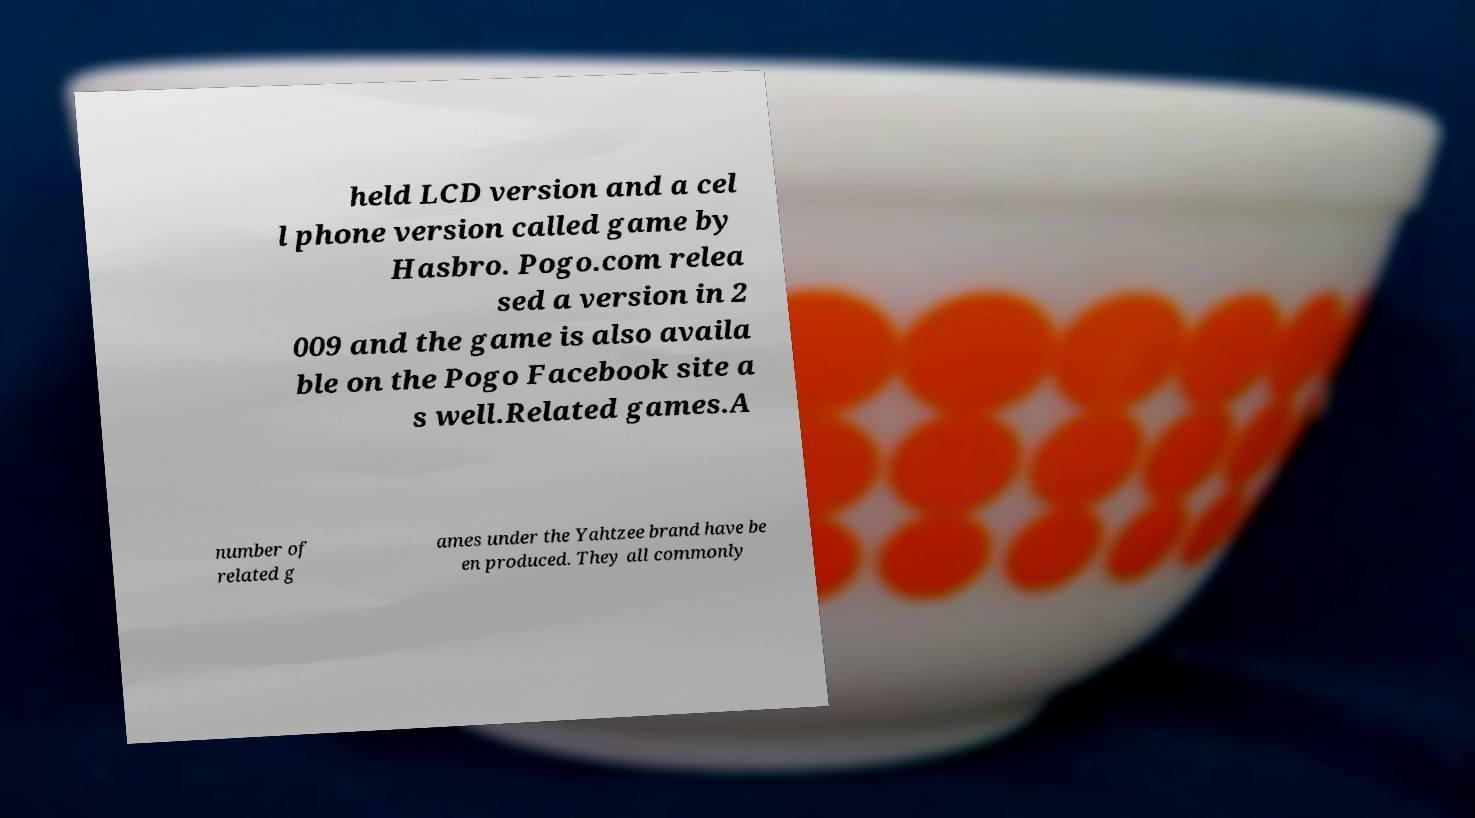Please read and relay the text visible in this image. What does it say? held LCD version and a cel l phone version called game by Hasbro. Pogo.com relea sed a version in 2 009 and the game is also availa ble on the Pogo Facebook site a s well.Related games.A number of related g ames under the Yahtzee brand have be en produced. They all commonly 